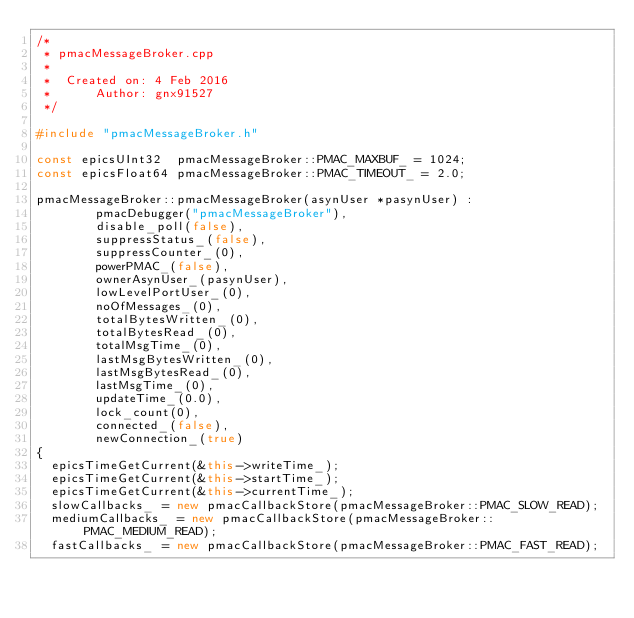<code> <loc_0><loc_0><loc_500><loc_500><_C++_>/*
 * pmacMessageBroker.cpp
 *
 *  Created on: 4 Feb 2016
 *      Author: gnx91527
 */

#include "pmacMessageBroker.h"

const epicsUInt32  pmacMessageBroker::PMAC_MAXBUF_ = 1024;
const epicsFloat64 pmacMessageBroker::PMAC_TIMEOUT_ = 2.0;

pmacMessageBroker::pmacMessageBroker(asynUser *pasynUser) :
        pmacDebugger("pmacMessageBroker"),
        disable_poll(false),
        suppressStatus_(false),
        suppressCounter_(0),
        powerPMAC_(false),
        ownerAsynUser_(pasynUser),
        lowLevelPortUser_(0),
        noOfMessages_(0),
        totalBytesWritten_(0),
        totalBytesRead_(0),
        totalMsgTime_(0),
        lastMsgBytesWritten_(0),
        lastMsgBytesRead_(0),
        lastMsgTime_(0),
        updateTime_(0.0),
        lock_count(0),
        connected_(false),
        newConnection_(true)
{
  epicsTimeGetCurrent(&this->writeTime_);
  epicsTimeGetCurrent(&this->startTime_);
  epicsTimeGetCurrent(&this->currentTime_);
  slowCallbacks_ = new pmacCallbackStore(pmacMessageBroker::PMAC_SLOW_READ);
  mediumCallbacks_ = new pmacCallbackStore(pmacMessageBroker::PMAC_MEDIUM_READ);
  fastCallbacks_ = new pmacCallbackStore(pmacMessageBroker::PMAC_FAST_READ);</code> 